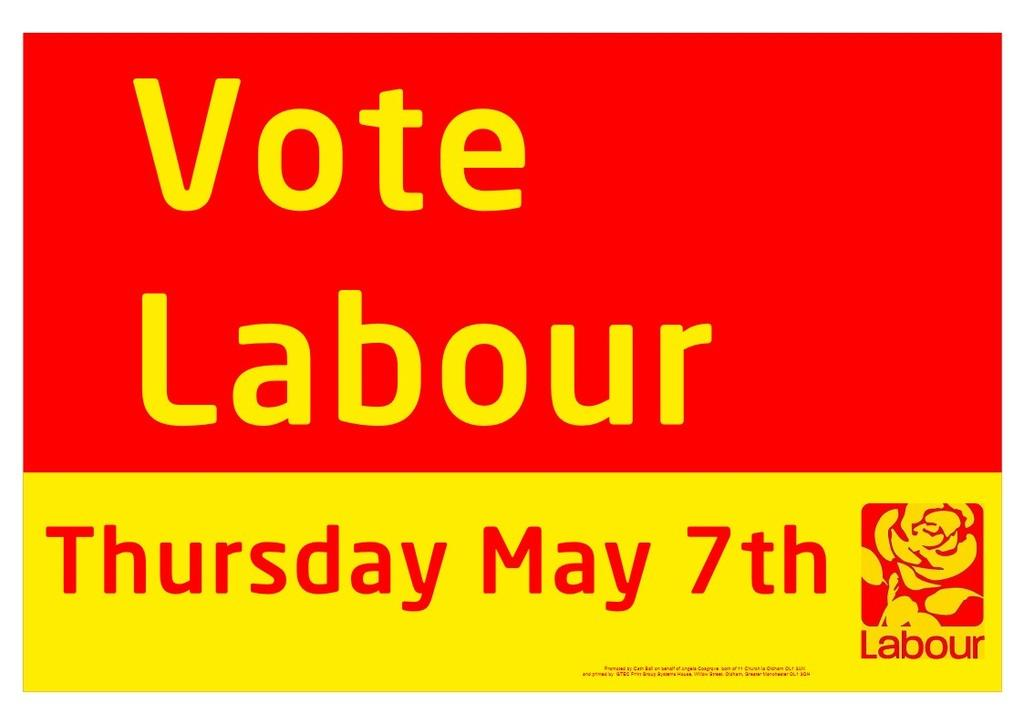<image>
Offer a succinct explanation of the picture presented. A red and yellow poster that reads vote labour. 